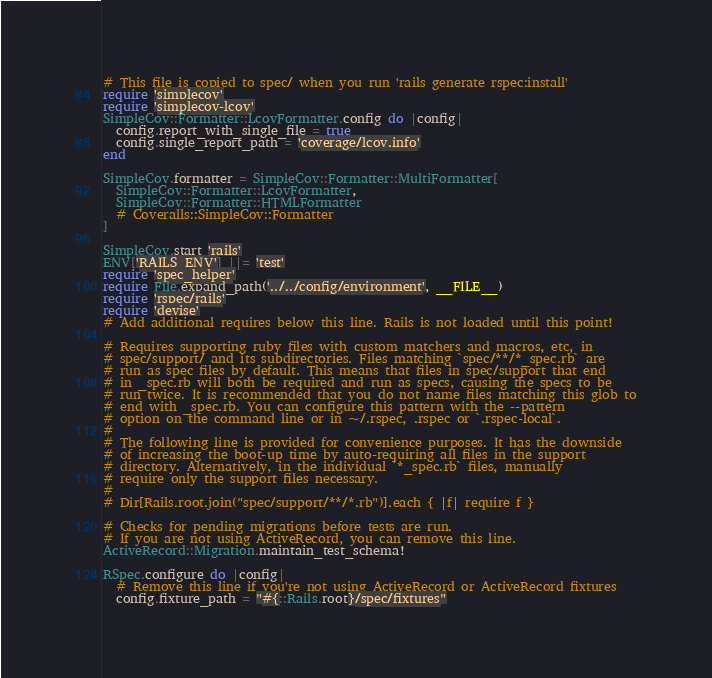Convert code to text. <code><loc_0><loc_0><loc_500><loc_500><_Ruby_># This file is copied to spec/ when you run 'rails generate rspec:install'
require 'simplecov'
require 'simplecov-lcov'
SimpleCov::Formatter::LcovFormatter.config do |config|
  config.report_with_single_file = true
  config.single_report_path = 'coverage/lcov.info'
end

SimpleCov.formatter = SimpleCov::Formatter::MultiFormatter[
  SimpleCov::Formatter::LcovFormatter,
  SimpleCov::Formatter::HTMLFormatter
  # Coveralls::SimpleCov::Formatter
]

SimpleCov.start 'rails'
ENV['RAILS_ENV'] ||= 'test'
require 'spec_helper'
require File.expand_path('../../config/environment', __FILE__)
require 'rspec/rails'
require 'devise'
# Add additional requires below this line. Rails is not loaded until this point!

# Requires supporting ruby files with custom matchers and macros, etc, in
# spec/support/ and its subdirectories. Files matching `spec/**/*_spec.rb` are
# run as spec files by default. This means that files in spec/support that end
# in _spec.rb will both be required and run as specs, causing the specs to be
# run twice. It is recommended that you do not name files matching this glob to
# end with _spec.rb. You can configure this pattern with the --pattern
# option on the command line or in ~/.rspec, .rspec or `.rspec-local`.
#
# The following line is provided for convenience purposes. It has the downside
# of increasing the boot-up time by auto-requiring all files in the support
# directory. Alternatively, in the individual `*_spec.rb` files, manually
# require only the support files necessary.
#
# Dir[Rails.root.join("spec/support/**/*.rb")].each { |f| require f }

# Checks for pending migrations before tests are run.
# If you are not using ActiveRecord, you can remove this line.
ActiveRecord::Migration.maintain_test_schema!

RSpec.configure do |config|
  # Remove this line if you're not using ActiveRecord or ActiveRecord fixtures
  config.fixture_path = "#{::Rails.root}/spec/fixtures"
</code> 